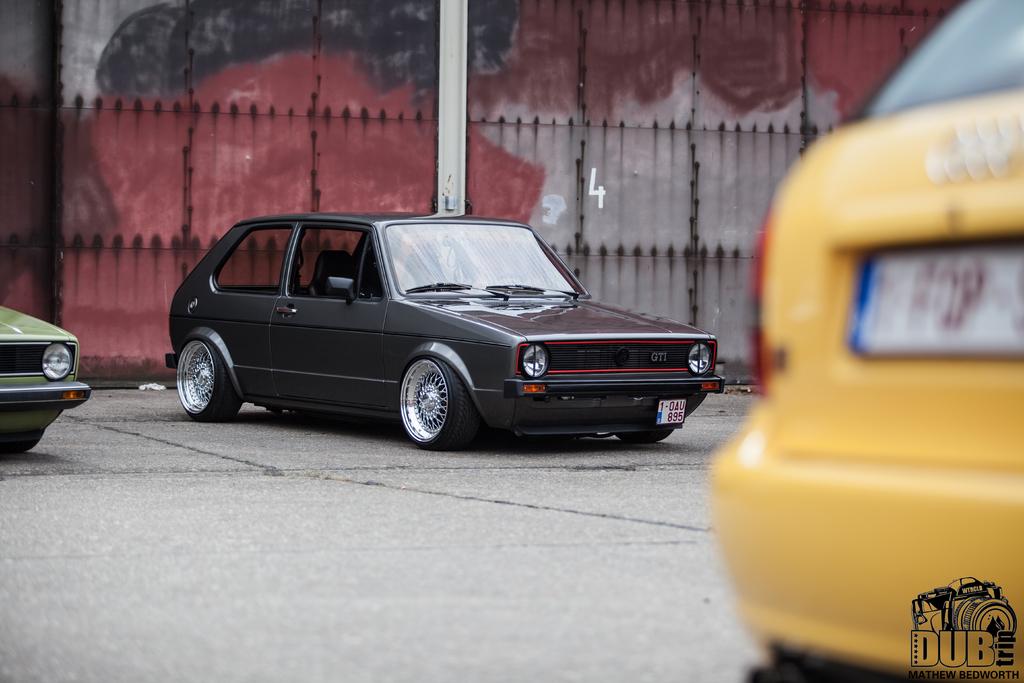Who took this photo?
Provide a short and direct response. Mathew bedworth. What number is on the building behind the black car?
Give a very brief answer. 4. 